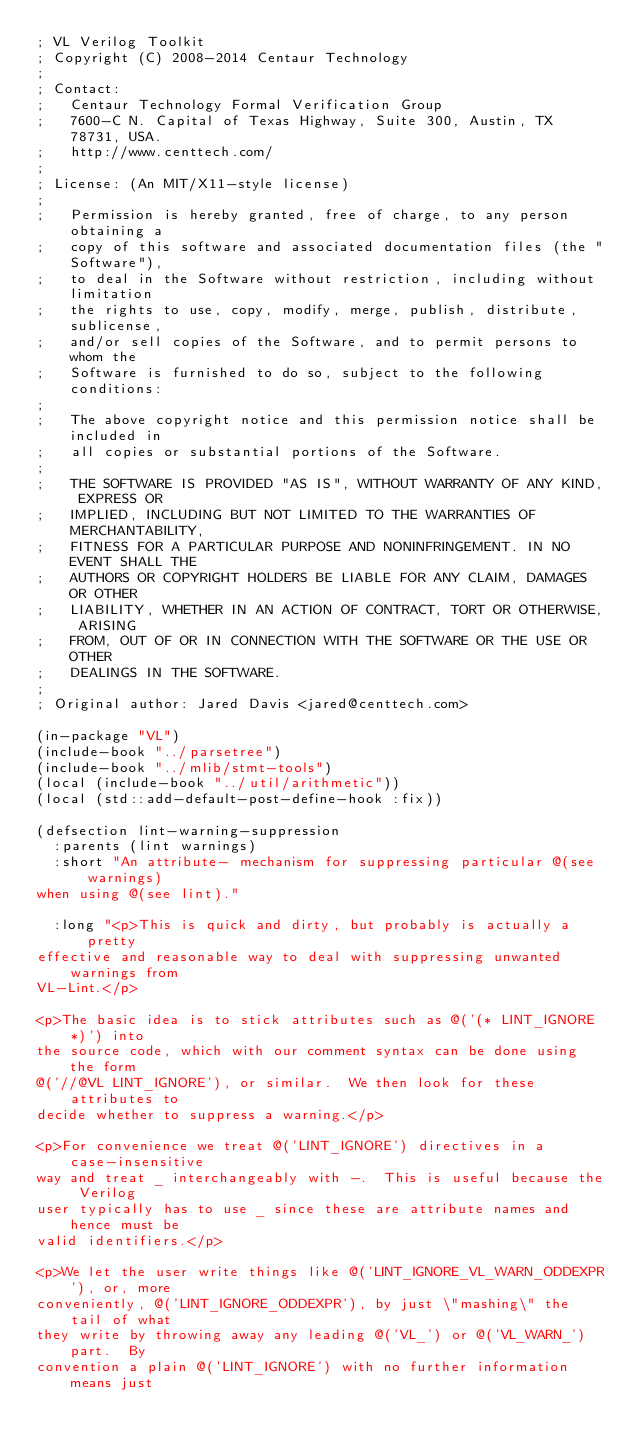Convert code to text. <code><loc_0><loc_0><loc_500><loc_500><_Lisp_>; VL Verilog Toolkit
; Copyright (C) 2008-2014 Centaur Technology
;
; Contact:
;   Centaur Technology Formal Verification Group
;   7600-C N. Capital of Texas Highway, Suite 300, Austin, TX 78731, USA.
;   http://www.centtech.com/
;
; License: (An MIT/X11-style license)
;
;   Permission is hereby granted, free of charge, to any person obtaining a
;   copy of this software and associated documentation files (the "Software"),
;   to deal in the Software without restriction, including without limitation
;   the rights to use, copy, modify, merge, publish, distribute, sublicense,
;   and/or sell copies of the Software, and to permit persons to whom the
;   Software is furnished to do so, subject to the following conditions:
;
;   The above copyright notice and this permission notice shall be included in
;   all copies or substantial portions of the Software.
;
;   THE SOFTWARE IS PROVIDED "AS IS", WITHOUT WARRANTY OF ANY KIND, EXPRESS OR
;   IMPLIED, INCLUDING BUT NOT LIMITED TO THE WARRANTIES OF MERCHANTABILITY,
;   FITNESS FOR A PARTICULAR PURPOSE AND NONINFRINGEMENT. IN NO EVENT SHALL THE
;   AUTHORS OR COPYRIGHT HOLDERS BE LIABLE FOR ANY CLAIM, DAMAGES OR OTHER
;   LIABILITY, WHETHER IN AN ACTION OF CONTRACT, TORT OR OTHERWISE, ARISING
;   FROM, OUT OF OR IN CONNECTION WITH THE SOFTWARE OR THE USE OR OTHER
;   DEALINGS IN THE SOFTWARE.
;
; Original author: Jared Davis <jared@centtech.com>

(in-package "VL")
(include-book "../parsetree")
(include-book "../mlib/stmt-tools")
(local (include-book "../util/arithmetic"))
(local (std::add-default-post-define-hook :fix))

(defsection lint-warning-suppression
  :parents (lint warnings)
  :short "An attribute- mechanism for suppressing particular @(see warnings)
when using @(see lint)."

  :long "<p>This is quick and dirty, but probably is actually a pretty
effective and reasonable way to deal with suppressing unwanted warnings from
VL-Lint.</p>

<p>The basic idea is to stick attributes such as @('(* LINT_IGNORE *)') into
the source code, which with our comment syntax can be done using the form
@('//@VL LINT_IGNORE'), or similar.  We then look for these attributes to
decide whether to suppress a warning.</p>

<p>For convenience we treat @('LINT_IGNORE') directives in a case-insensitive
way and treat _ interchangeably with -.  This is useful because the Verilog
user typically has to use _ since these are attribute names and hence must be
valid identifiers.</p>

<p>We let the user write things like @('LINT_IGNORE_VL_WARN_ODDEXPR'), or, more
conveniently, @('LINT_IGNORE_ODDEXPR'), by just \"mashing\" the tail of what
they write by throwing away any leading @('VL_') or @('VL_WARN_') part.  By
convention a plain @('LINT_IGNORE') with no further information means just</code> 